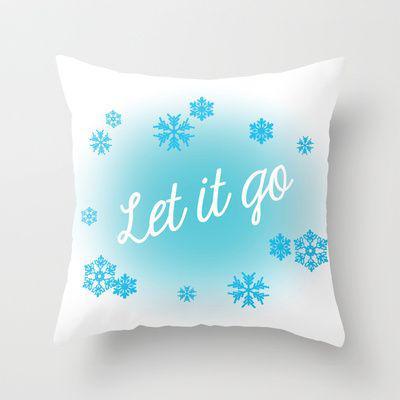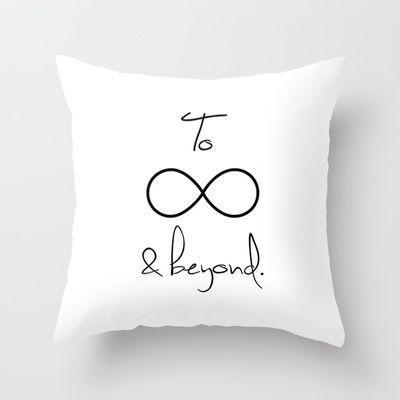The first image is the image on the left, the second image is the image on the right. Analyze the images presented: Is the assertion "The pillows in the image on the left have words on them." valid? Answer yes or no. Yes. The first image is the image on the left, the second image is the image on the right. Evaluate the accuracy of this statement regarding the images: "The lefthand image shows a pillow decorated with at least one symmetrical sky-blue shape that resembles a snowflake.". Is it true? Answer yes or no. Yes. 